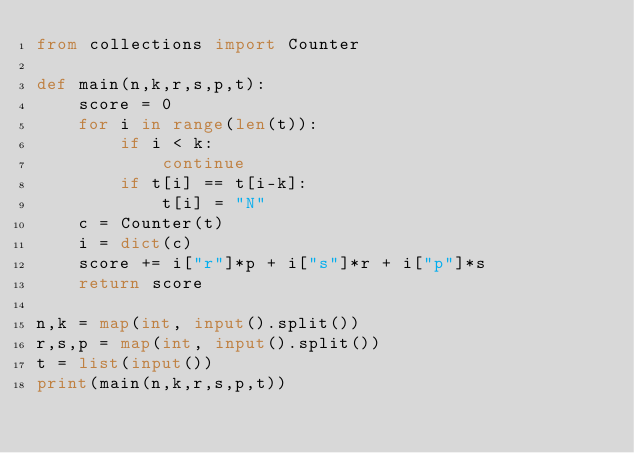Convert code to text. <code><loc_0><loc_0><loc_500><loc_500><_Python_>from collections import Counter

def main(n,k,r,s,p,t):
    score = 0
    for i in range(len(t)):
        if i < k:
            continue
        if t[i] == t[i-k]:
            t[i] = "N"
    c = Counter(t)
    i = dict(c)
    score += i["r"]*p + i["s"]*r + i["p"]*s
    return score
    
n,k = map(int, input().split())
r,s,p = map(int, input().split())
t = list(input())
print(main(n,k,r,s,p,t))</code> 